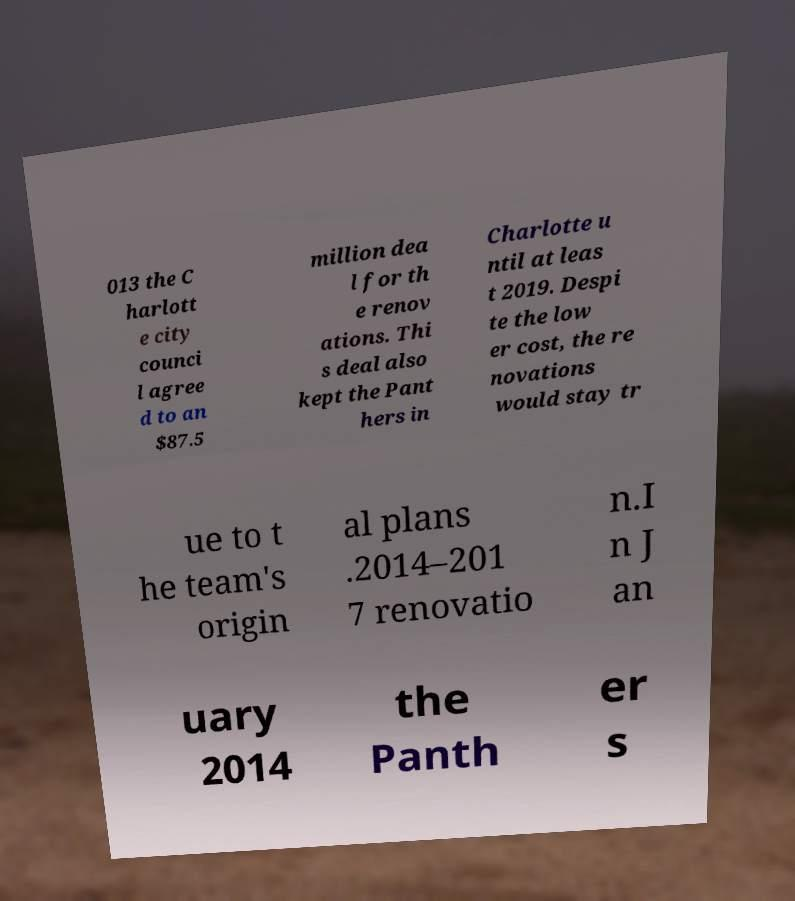Could you extract and type out the text from this image? 013 the C harlott e city counci l agree d to an $87.5 million dea l for th e renov ations. Thi s deal also kept the Pant hers in Charlotte u ntil at leas t 2019. Despi te the low er cost, the re novations would stay tr ue to t he team's origin al plans .2014–201 7 renovatio n.I n J an uary 2014 the Panth er s 